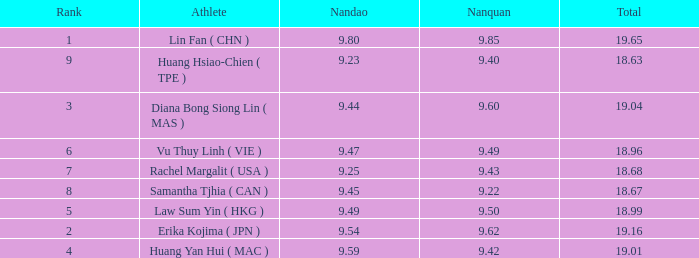Which Nanquan has a Nandao larger than 9.49, and a Rank of 4? 9.42. Would you be able to parse every entry in this table? {'header': ['Rank', 'Athlete', 'Nandao', 'Nanquan', 'Total'], 'rows': [['1', 'Lin Fan ( CHN )', '9.80', '9.85', '19.65'], ['9', 'Huang Hsiao-Chien ( TPE )', '9.23', '9.40', '18.63'], ['3', 'Diana Bong Siong Lin ( MAS )', '9.44', '9.60', '19.04'], ['6', 'Vu Thuy Linh ( VIE )', '9.47', '9.49', '18.96'], ['7', 'Rachel Margalit ( USA )', '9.25', '9.43', '18.68'], ['8', 'Samantha Tjhia ( CAN )', '9.45', '9.22', '18.67'], ['5', 'Law Sum Yin ( HKG )', '9.49', '9.50', '18.99'], ['2', 'Erika Kojima ( JPN )', '9.54', '9.62', '19.16'], ['4', 'Huang Yan Hui ( MAC )', '9.59', '9.42', '19.01']]} 